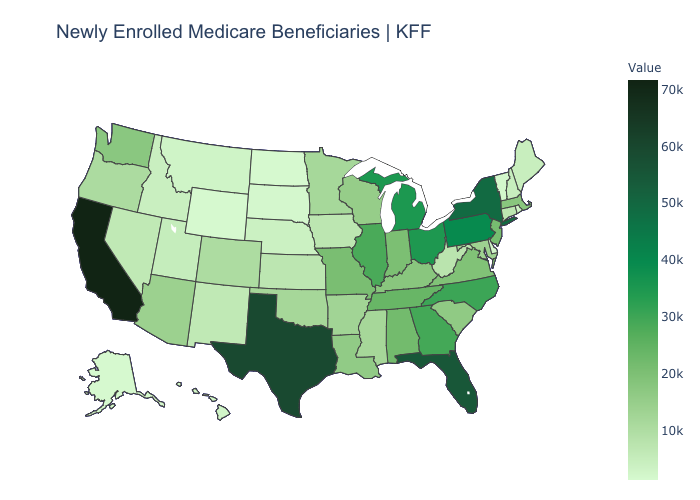Does Hawaii have a higher value than Illinois?
Answer briefly. No. Does Ohio have the lowest value in the USA?
Be succinct. No. Which states have the lowest value in the West?
Keep it brief. Alaska. Which states have the highest value in the USA?
Quick response, please. California. Which states have the lowest value in the USA?
Write a very short answer. Alaska. Among the states that border Missouri , does Illinois have the highest value?
Keep it brief. Yes. Which states have the lowest value in the South?
Concise answer only. Delaware. 